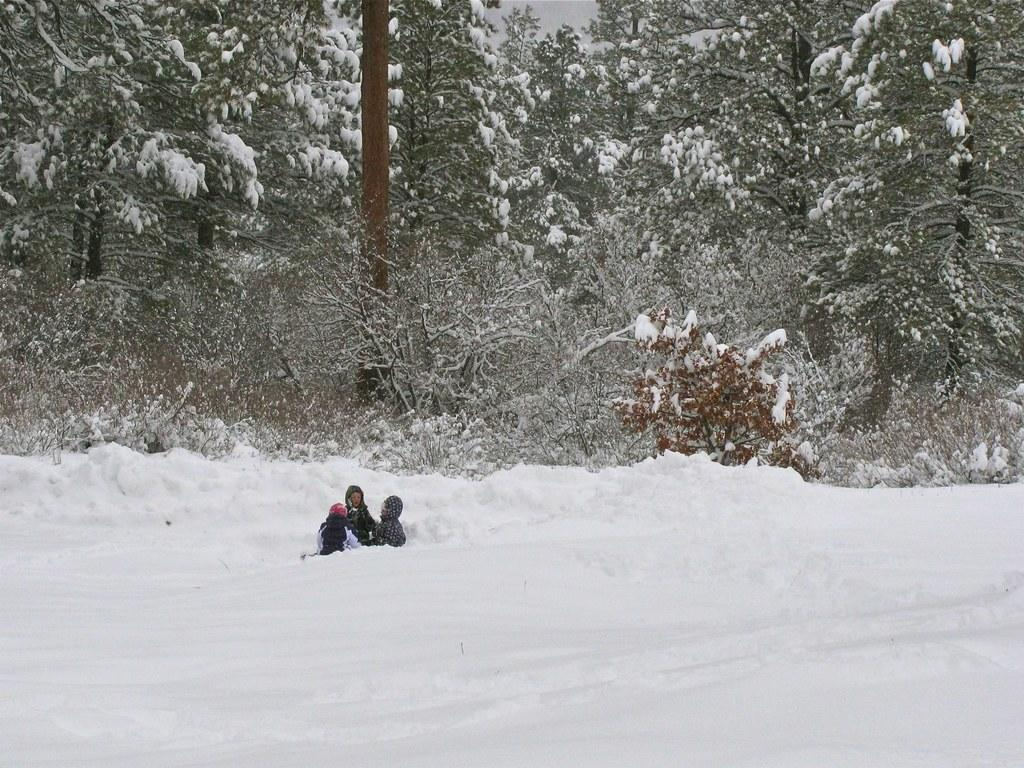What is the main feature of the landscape in the image? There is thick snow in the image. What are the two people doing in the image? The two people are laying on the snow. What type of vegetation can be seen in the image? There are trees visible in the image. How are the trees affected by the weather conditions? The trees are covered with ice. What color is the lettuce in the image? There is no lettuce present in the image. How many sparks can be seen coming from the trees in the image? There are no sparks visible in the image; the trees are covered with ice. 